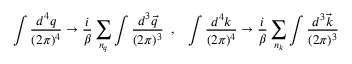<formula> <loc_0><loc_0><loc_500><loc_500>\int { \frac { d ^ { 4 } q } { ( 2 \pi ) ^ { 4 } } } \rightarrow { \frac { i } { \beta } } \sum _ { n _ { q } } \int { \frac { d ^ { 3 } { \vec { q } } } { ( 2 \pi ) ^ { 3 } } } \, , \, \int { \frac { d ^ { 4 } k } { ( 2 \pi ) ^ { 4 } } } \rightarrow { \frac { i } { \beta } } \sum _ { n _ { k } } \int { \frac { d ^ { 3 } { \vec { k } } } { ( 2 \pi ) ^ { 3 } } }</formula> 